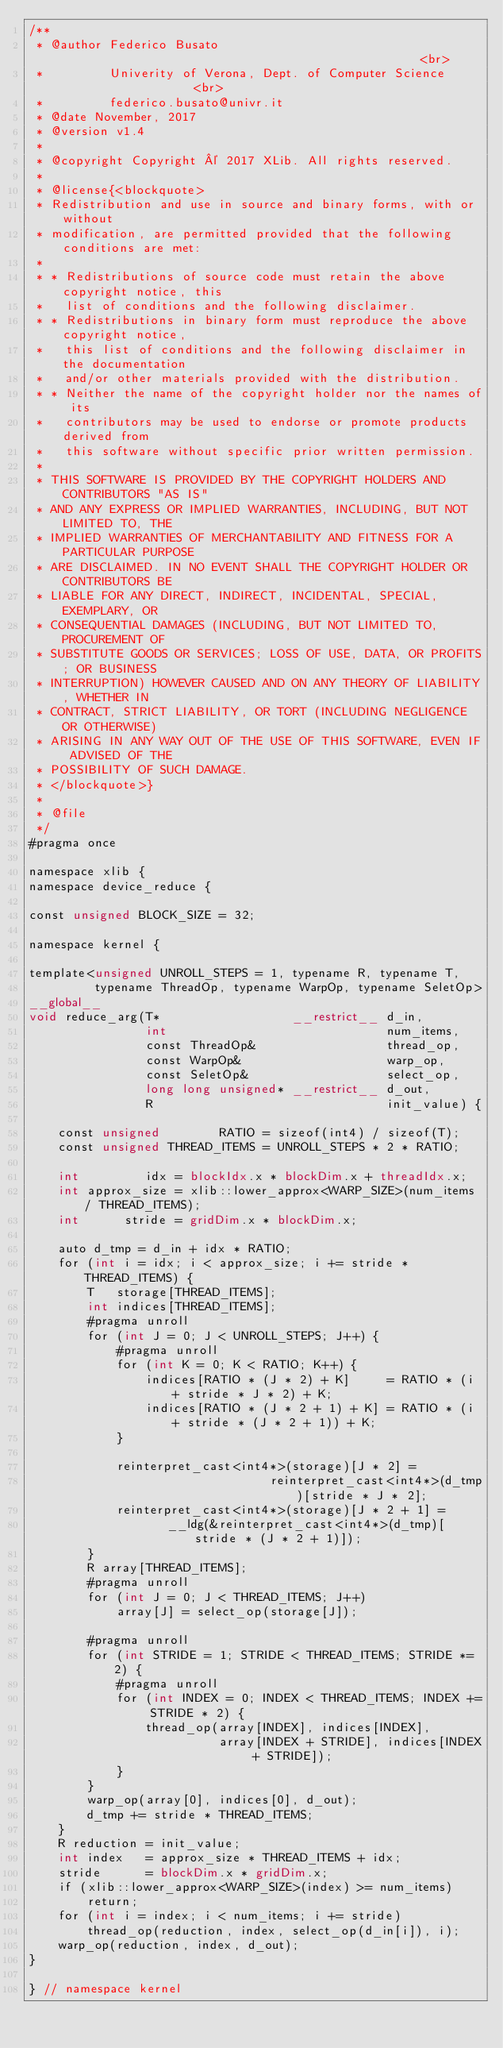Convert code to text. <code><loc_0><loc_0><loc_500><loc_500><_Cuda_>/**
 * @author Federico Busato                                                  <br>
 *         Univerity of Verona, Dept. of Computer Science                   <br>
 *         federico.busato@univr.it
 * @date November, 2017
 * @version v1.4
 *
 * @copyright Copyright © 2017 XLib. All rights reserved.
 *
 * @license{<blockquote>
 * Redistribution and use in source and binary forms, with or without
 * modification, are permitted provided that the following conditions are met:
 *
 * * Redistributions of source code must retain the above copyright notice, this
 *   list of conditions and the following disclaimer.
 * * Redistributions in binary form must reproduce the above copyright notice,
 *   this list of conditions and the following disclaimer in the documentation
 *   and/or other materials provided with the distribution.
 * * Neither the name of the copyright holder nor the names of its
 *   contributors may be used to endorse or promote products derived from
 *   this software without specific prior written permission.
 *
 * THIS SOFTWARE IS PROVIDED BY THE COPYRIGHT HOLDERS AND CONTRIBUTORS "AS IS"
 * AND ANY EXPRESS OR IMPLIED WARRANTIES, INCLUDING, BUT NOT LIMITED TO, THE
 * IMPLIED WARRANTIES OF MERCHANTABILITY AND FITNESS FOR A PARTICULAR PURPOSE
 * ARE DISCLAIMED. IN NO EVENT SHALL THE COPYRIGHT HOLDER OR CONTRIBUTORS BE
 * LIABLE FOR ANY DIRECT, INDIRECT, INCIDENTAL, SPECIAL, EXEMPLARY, OR
 * CONSEQUENTIAL DAMAGES (INCLUDING, BUT NOT LIMITED TO, PROCUREMENT OF
 * SUBSTITUTE GOODS OR SERVICES; LOSS OF USE, DATA, OR PROFITS; OR BUSINESS
 * INTERRUPTION) HOWEVER CAUSED AND ON ANY THEORY OF LIABILITY, WHETHER IN
 * CONTRACT, STRICT LIABILITY, OR TORT (INCLUDING NEGLIGENCE OR OTHERWISE)
 * ARISING IN ANY WAY OUT OF THE USE OF THIS SOFTWARE, EVEN IF ADVISED OF THE
 * POSSIBILITY OF SUCH DAMAGE.
 * </blockquote>}
 *
 * @file
 */
#pragma once

namespace xlib {
namespace device_reduce {

const unsigned BLOCK_SIZE = 32;

namespace kernel {

template<unsigned UNROLL_STEPS = 1, typename R, typename T,
         typename ThreadOp, typename WarpOp, typename SeletOp>
__global__
void reduce_arg(T*                  __restrict__ d_in,
                int                              num_items,
                const ThreadOp&                  thread_op,
                const WarpOp&                    warp_op,
                const SeletOp&                   select_op,
                long long unsigned* __restrict__ d_out,
                R                                init_value) {

    const unsigned        RATIO = sizeof(int4) / sizeof(T);
    const unsigned THREAD_ITEMS = UNROLL_STEPS * 2 * RATIO;

    int         idx = blockIdx.x * blockDim.x + threadIdx.x;
    int approx_size = xlib::lower_approx<WARP_SIZE>(num_items / THREAD_ITEMS);
    int      stride = gridDim.x * blockDim.x;

    auto d_tmp = d_in + idx * RATIO;
    for (int i = idx; i < approx_size; i += stride * THREAD_ITEMS) {
        T   storage[THREAD_ITEMS];
        int indices[THREAD_ITEMS];
        #pragma unroll
        for (int J = 0; J < UNROLL_STEPS; J++) {
            #pragma unroll
            for (int K = 0; K < RATIO; K++) {
                indices[RATIO * (J * 2) + K]     = RATIO * (i + stride * J * 2) + K;
                indices[RATIO * (J * 2 + 1) + K] = RATIO * (i + stride * (J * 2 + 1)) + K;
            }

            reinterpret_cast<int4*>(storage)[J * 2] =
                                 reinterpret_cast<int4*>(d_tmp)[stride * J * 2];
            reinterpret_cast<int4*>(storage)[J * 2 + 1] =
                   __ldg(&reinterpret_cast<int4*>(d_tmp)[stride * (J * 2 + 1)]);
        }
        R array[THREAD_ITEMS];
        #pragma unroll
        for (int J = 0; J < THREAD_ITEMS; J++)
            array[J] = select_op(storage[J]);

        #pragma unroll
        for (int STRIDE = 1; STRIDE < THREAD_ITEMS; STRIDE *= 2) {
            #pragma unroll
            for (int INDEX = 0; INDEX < THREAD_ITEMS; INDEX += STRIDE * 2) {
                thread_op(array[INDEX], indices[INDEX],
                          array[INDEX + STRIDE], indices[INDEX + STRIDE]);
            }
        }
        warp_op(array[0], indices[0], d_out);
        d_tmp += stride * THREAD_ITEMS;
    }
    R reduction = init_value;
    int index   = approx_size * THREAD_ITEMS + idx;
    stride      = blockDim.x * gridDim.x;
    if (xlib::lower_approx<WARP_SIZE>(index) >= num_items)
        return;
    for (int i = index; i < num_items; i += stride)
        thread_op(reduction, index, select_op(d_in[i]), i);
    warp_op(reduction, index, d_out);
}

} // namespace kernel
</code> 